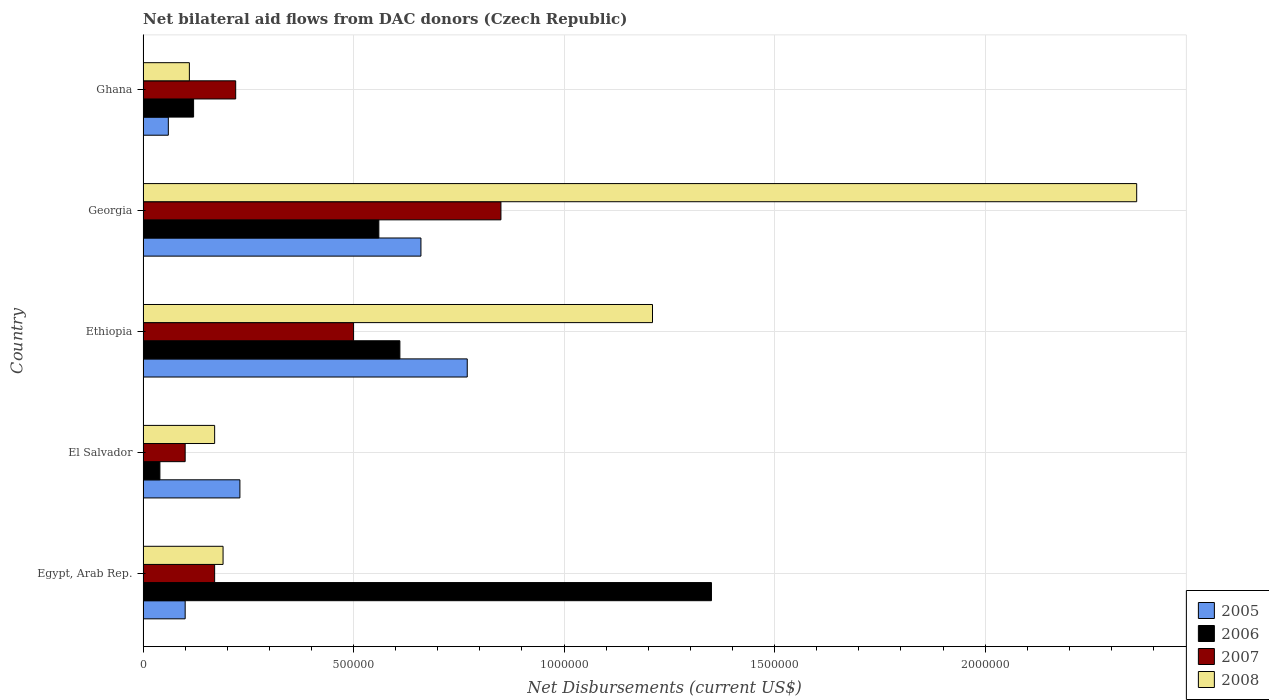How many different coloured bars are there?
Offer a very short reply. 4. How many groups of bars are there?
Offer a very short reply. 5. Are the number of bars per tick equal to the number of legend labels?
Provide a succinct answer. Yes. How many bars are there on the 5th tick from the top?
Provide a succinct answer. 4. How many bars are there on the 1st tick from the bottom?
Offer a very short reply. 4. What is the label of the 5th group of bars from the top?
Provide a succinct answer. Egypt, Arab Rep. Across all countries, what is the maximum net bilateral aid flows in 2008?
Give a very brief answer. 2.36e+06. Across all countries, what is the minimum net bilateral aid flows in 2005?
Offer a very short reply. 6.00e+04. In which country was the net bilateral aid flows in 2007 maximum?
Your answer should be very brief. Georgia. In which country was the net bilateral aid flows in 2007 minimum?
Your answer should be very brief. El Salvador. What is the total net bilateral aid flows in 2005 in the graph?
Your response must be concise. 1.82e+06. What is the difference between the net bilateral aid flows in 2008 in El Salvador and the net bilateral aid flows in 2006 in Ethiopia?
Give a very brief answer. -4.40e+05. What is the average net bilateral aid flows in 2005 per country?
Offer a very short reply. 3.64e+05. What is the difference between the net bilateral aid flows in 2008 and net bilateral aid flows in 2005 in Egypt, Arab Rep.?
Provide a succinct answer. 9.00e+04. What is the ratio of the net bilateral aid flows in 2007 in Georgia to that in Ghana?
Give a very brief answer. 3.86. What is the difference between the highest and the second highest net bilateral aid flows in 2006?
Make the answer very short. 7.40e+05. What is the difference between the highest and the lowest net bilateral aid flows in 2006?
Your response must be concise. 1.31e+06. In how many countries, is the net bilateral aid flows in 2008 greater than the average net bilateral aid flows in 2008 taken over all countries?
Provide a succinct answer. 2. Is the sum of the net bilateral aid flows in 2006 in Ethiopia and Ghana greater than the maximum net bilateral aid flows in 2008 across all countries?
Your answer should be compact. No. Is it the case that in every country, the sum of the net bilateral aid flows in 2008 and net bilateral aid flows in 2006 is greater than the sum of net bilateral aid flows in 2005 and net bilateral aid flows in 2007?
Your answer should be very brief. Yes. What does the 1st bar from the top in El Salvador represents?
Offer a very short reply. 2008. Is it the case that in every country, the sum of the net bilateral aid flows in 2005 and net bilateral aid flows in 2008 is greater than the net bilateral aid flows in 2006?
Give a very brief answer. No. How many bars are there?
Give a very brief answer. 20. Are all the bars in the graph horizontal?
Provide a short and direct response. Yes. How many countries are there in the graph?
Keep it short and to the point. 5. What is the difference between two consecutive major ticks on the X-axis?
Ensure brevity in your answer.  5.00e+05. Does the graph contain any zero values?
Keep it short and to the point. No. Where does the legend appear in the graph?
Your response must be concise. Bottom right. What is the title of the graph?
Your response must be concise. Net bilateral aid flows from DAC donors (Czech Republic). Does "1965" appear as one of the legend labels in the graph?
Your answer should be very brief. No. What is the label or title of the X-axis?
Your answer should be very brief. Net Disbursements (current US$). What is the label or title of the Y-axis?
Provide a succinct answer. Country. What is the Net Disbursements (current US$) in 2005 in Egypt, Arab Rep.?
Your answer should be compact. 1.00e+05. What is the Net Disbursements (current US$) in 2006 in Egypt, Arab Rep.?
Offer a very short reply. 1.35e+06. What is the Net Disbursements (current US$) of 2006 in El Salvador?
Your response must be concise. 4.00e+04. What is the Net Disbursements (current US$) of 2007 in El Salvador?
Offer a terse response. 1.00e+05. What is the Net Disbursements (current US$) of 2008 in El Salvador?
Keep it short and to the point. 1.70e+05. What is the Net Disbursements (current US$) of 2005 in Ethiopia?
Your answer should be very brief. 7.70e+05. What is the Net Disbursements (current US$) of 2008 in Ethiopia?
Ensure brevity in your answer.  1.21e+06. What is the Net Disbursements (current US$) in 2005 in Georgia?
Provide a succinct answer. 6.60e+05. What is the Net Disbursements (current US$) of 2006 in Georgia?
Offer a terse response. 5.60e+05. What is the Net Disbursements (current US$) of 2007 in Georgia?
Keep it short and to the point. 8.50e+05. What is the Net Disbursements (current US$) in 2008 in Georgia?
Your answer should be very brief. 2.36e+06. What is the Net Disbursements (current US$) of 2005 in Ghana?
Make the answer very short. 6.00e+04. Across all countries, what is the maximum Net Disbursements (current US$) in 2005?
Offer a terse response. 7.70e+05. Across all countries, what is the maximum Net Disbursements (current US$) in 2006?
Provide a short and direct response. 1.35e+06. Across all countries, what is the maximum Net Disbursements (current US$) of 2007?
Offer a terse response. 8.50e+05. Across all countries, what is the maximum Net Disbursements (current US$) in 2008?
Your answer should be very brief. 2.36e+06. Across all countries, what is the minimum Net Disbursements (current US$) of 2006?
Keep it short and to the point. 4.00e+04. What is the total Net Disbursements (current US$) in 2005 in the graph?
Provide a succinct answer. 1.82e+06. What is the total Net Disbursements (current US$) of 2006 in the graph?
Provide a short and direct response. 2.68e+06. What is the total Net Disbursements (current US$) in 2007 in the graph?
Offer a terse response. 1.84e+06. What is the total Net Disbursements (current US$) in 2008 in the graph?
Offer a terse response. 4.04e+06. What is the difference between the Net Disbursements (current US$) in 2005 in Egypt, Arab Rep. and that in El Salvador?
Provide a succinct answer. -1.30e+05. What is the difference between the Net Disbursements (current US$) of 2006 in Egypt, Arab Rep. and that in El Salvador?
Offer a terse response. 1.31e+06. What is the difference between the Net Disbursements (current US$) of 2007 in Egypt, Arab Rep. and that in El Salvador?
Ensure brevity in your answer.  7.00e+04. What is the difference between the Net Disbursements (current US$) of 2008 in Egypt, Arab Rep. and that in El Salvador?
Provide a short and direct response. 2.00e+04. What is the difference between the Net Disbursements (current US$) of 2005 in Egypt, Arab Rep. and that in Ethiopia?
Provide a short and direct response. -6.70e+05. What is the difference between the Net Disbursements (current US$) of 2006 in Egypt, Arab Rep. and that in Ethiopia?
Keep it short and to the point. 7.40e+05. What is the difference between the Net Disbursements (current US$) in 2007 in Egypt, Arab Rep. and that in Ethiopia?
Ensure brevity in your answer.  -3.30e+05. What is the difference between the Net Disbursements (current US$) in 2008 in Egypt, Arab Rep. and that in Ethiopia?
Your response must be concise. -1.02e+06. What is the difference between the Net Disbursements (current US$) in 2005 in Egypt, Arab Rep. and that in Georgia?
Your answer should be very brief. -5.60e+05. What is the difference between the Net Disbursements (current US$) in 2006 in Egypt, Arab Rep. and that in Georgia?
Ensure brevity in your answer.  7.90e+05. What is the difference between the Net Disbursements (current US$) in 2007 in Egypt, Arab Rep. and that in Georgia?
Keep it short and to the point. -6.80e+05. What is the difference between the Net Disbursements (current US$) in 2008 in Egypt, Arab Rep. and that in Georgia?
Ensure brevity in your answer.  -2.17e+06. What is the difference between the Net Disbursements (current US$) of 2005 in Egypt, Arab Rep. and that in Ghana?
Offer a very short reply. 4.00e+04. What is the difference between the Net Disbursements (current US$) of 2006 in Egypt, Arab Rep. and that in Ghana?
Make the answer very short. 1.23e+06. What is the difference between the Net Disbursements (current US$) of 2005 in El Salvador and that in Ethiopia?
Your answer should be very brief. -5.40e+05. What is the difference between the Net Disbursements (current US$) in 2006 in El Salvador and that in Ethiopia?
Offer a very short reply. -5.70e+05. What is the difference between the Net Disbursements (current US$) of 2007 in El Salvador and that in Ethiopia?
Offer a terse response. -4.00e+05. What is the difference between the Net Disbursements (current US$) in 2008 in El Salvador and that in Ethiopia?
Your answer should be very brief. -1.04e+06. What is the difference between the Net Disbursements (current US$) in 2005 in El Salvador and that in Georgia?
Provide a short and direct response. -4.30e+05. What is the difference between the Net Disbursements (current US$) in 2006 in El Salvador and that in Georgia?
Your response must be concise. -5.20e+05. What is the difference between the Net Disbursements (current US$) of 2007 in El Salvador and that in Georgia?
Provide a succinct answer. -7.50e+05. What is the difference between the Net Disbursements (current US$) of 2008 in El Salvador and that in Georgia?
Your answer should be very brief. -2.19e+06. What is the difference between the Net Disbursements (current US$) in 2005 in El Salvador and that in Ghana?
Make the answer very short. 1.70e+05. What is the difference between the Net Disbursements (current US$) of 2006 in Ethiopia and that in Georgia?
Provide a succinct answer. 5.00e+04. What is the difference between the Net Disbursements (current US$) in 2007 in Ethiopia and that in Georgia?
Your response must be concise. -3.50e+05. What is the difference between the Net Disbursements (current US$) of 2008 in Ethiopia and that in Georgia?
Your answer should be compact. -1.15e+06. What is the difference between the Net Disbursements (current US$) in 2005 in Ethiopia and that in Ghana?
Make the answer very short. 7.10e+05. What is the difference between the Net Disbursements (current US$) of 2008 in Ethiopia and that in Ghana?
Make the answer very short. 1.10e+06. What is the difference between the Net Disbursements (current US$) of 2005 in Georgia and that in Ghana?
Offer a terse response. 6.00e+05. What is the difference between the Net Disbursements (current US$) in 2006 in Georgia and that in Ghana?
Offer a very short reply. 4.40e+05. What is the difference between the Net Disbursements (current US$) in 2007 in Georgia and that in Ghana?
Your answer should be compact. 6.30e+05. What is the difference between the Net Disbursements (current US$) of 2008 in Georgia and that in Ghana?
Provide a succinct answer. 2.25e+06. What is the difference between the Net Disbursements (current US$) of 2005 in Egypt, Arab Rep. and the Net Disbursements (current US$) of 2008 in El Salvador?
Your answer should be very brief. -7.00e+04. What is the difference between the Net Disbursements (current US$) in 2006 in Egypt, Arab Rep. and the Net Disbursements (current US$) in 2007 in El Salvador?
Keep it short and to the point. 1.25e+06. What is the difference between the Net Disbursements (current US$) in 2006 in Egypt, Arab Rep. and the Net Disbursements (current US$) in 2008 in El Salvador?
Your answer should be very brief. 1.18e+06. What is the difference between the Net Disbursements (current US$) of 2005 in Egypt, Arab Rep. and the Net Disbursements (current US$) of 2006 in Ethiopia?
Your response must be concise. -5.10e+05. What is the difference between the Net Disbursements (current US$) in 2005 in Egypt, Arab Rep. and the Net Disbursements (current US$) in 2007 in Ethiopia?
Provide a succinct answer. -4.00e+05. What is the difference between the Net Disbursements (current US$) of 2005 in Egypt, Arab Rep. and the Net Disbursements (current US$) of 2008 in Ethiopia?
Your response must be concise. -1.11e+06. What is the difference between the Net Disbursements (current US$) of 2006 in Egypt, Arab Rep. and the Net Disbursements (current US$) of 2007 in Ethiopia?
Provide a short and direct response. 8.50e+05. What is the difference between the Net Disbursements (current US$) of 2007 in Egypt, Arab Rep. and the Net Disbursements (current US$) of 2008 in Ethiopia?
Provide a succinct answer. -1.04e+06. What is the difference between the Net Disbursements (current US$) in 2005 in Egypt, Arab Rep. and the Net Disbursements (current US$) in 2006 in Georgia?
Keep it short and to the point. -4.60e+05. What is the difference between the Net Disbursements (current US$) of 2005 in Egypt, Arab Rep. and the Net Disbursements (current US$) of 2007 in Georgia?
Give a very brief answer. -7.50e+05. What is the difference between the Net Disbursements (current US$) in 2005 in Egypt, Arab Rep. and the Net Disbursements (current US$) in 2008 in Georgia?
Give a very brief answer. -2.26e+06. What is the difference between the Net Disbursements (current US$) in 2006 in Egypt, Arab Rep. and the Net Disbursements (current US$) in 2007 in Georgia?
Offer a terse response. 5.00e+05. What is the difference between the Net Disbursements (current US$) of 2006 in Egypt, Arab Rep. and the Net Disbursements (current US$) of 2008 in Georgia?
Keep it short and to the point. -1.01e+06. What is the difference between the Net Disbursements (current US$) in 2007 in Egypt, Arab Rep. and the Net Disbursements (current US$) in 2008 in Georgia?
Make the answer very short. -2.19e+06. What is the difference between the Net Disbursements (current US$) in 2005 in Egypt, Arab Rep. and the Net Disbursements (current US$) in 2006 in Ghana?
Give a very brief answer. -2.00e+04. What is the difference between the Net Disbursements (current US$) in 2005 in Egypt, Arab Rep. and the Net Disbursements (current US$) in 2008 in Ghana?
Offer a very short reply. -10000. What is the difference between the Net Disbursements (current US$) of 2006 in Egypt, Arab Rep. and the Net Disbursements (current US$) of 2007 in Ghana?
Provide a short and direct response. 1.13e+06. What is the difference between the Net Disbursements (current US$) of 2006 in Egypt, Arab Rep. and the Net Disbursements (current US$) of 2008 in Ghana?
Provide a succinct answer. 1.24e+06. What is the difference between the Net Disbursements (current US$) in 2005 in El Salvador and the Net Disbursements (current US$) in 2006 in Ethiopia?
Make the answer very short. -3.80e+05. What is the difference between the Net Disbursements (current US$) in 2005 in El Salvador and the Net Disbursements (current US$) in 2007 in Ethiopia?
Your response must be concise. -2.70e+05. What is the difference between the Net Disbursements (current US$) of 2005 in El Salvador and the Net Disbursements (current US$) of 2008 in Ethiopia?
Your answer should be compact. -9.80e+05. What is the difference between the Net Disbursements (current US$) in 2006 in El Salvador and the Net Disbursements (current US$) in 2007 in Ethiopia?
Provide a short and direct response. -4.60e+05. What is the difference between the Net Disbursements (current US$) in 2006 in El Salvador and the Net Disbursements (current US$) in 2008 in Ethiopia?
Give a very brief answer. -1.17e+06. What is the difference between the Net Disbursements (current US$) in 2007 in El Salvador and the Net Disbursements (current US$) in 2008 in Ethiopia?
Your answer should be very brief. -1.11e+06. What is the difference between the Net Disbursements (current US$) of 2005 in El Salvador and the Net Disbursements (current US$) of 2006 in Georgia?
Your answer should be compact. -3.30e+05. What is the difference between the Net Disbursements (current US$) in 2005 in El Salvador and the Net Disbursements (current US$) in 2007 in Georgia?
Provide a short and direct response. -6.20e+05. What is the difference between the Net Disbursements (current US$) of 2005 in El Salvador and the Net Disbursements (current US$) of 2008 in Georgia?
Ensure brevity in your answer.  -2.13e+06. What is the difference between the Net Disbursements (current US$) of 2006 in El Salvador and the Net Disbursements (current US$) of 2007 in Georgia?
Offer a terse response. -8.10e+05. What is the difference between the Net Disbursements (current US$) of 2006 in El Salvador and the Net Disbursements (current US$) of 2008 in Georgia?
Provide a succinct answer. -2.32e+06. What is the difference between the Net Disbursements (current US$) in 2007 in El Salvador and the Net Disbursements (current US$) in 2008 in Georgia?
Provide a succinct answer. -2.26e+06. What is the difference between the Net Disbursements (current US$) in 2005 in El Salvador and the Net Disbursements (current US$) in 2006 in Ghana?
Your answer should be very brief. 1.10e+05. What is the difference between the Net Disbursements (current US$) in 2005 in Ethiopia and the Net Disbursements (current US$) in 2006 in Georgia?
Keep it short and to the point. 2.10e+05. What is the difference between the Net Disbursements (current US$) in 2005 in Ethiopia and the Net Disbursements (current US$) in 2008 in Georgia?
Your answer should be very brief. -1.59e+06. What is the difference between the Net Disbursements (current US$) of 2006 in Ethiopia and the Net Disbursements (current US$) of 2008 in Georgia?
Your answer should be very brief. -1.75e+06. What is the difference between the Net Disbursements (current US$) of 2007 in Ethiopia and the Net Disbursements (current US$) of 2008 in Georgia?
Offer a very short reply. -1.86e+06. What is the difference between the Net Disbursements (current US$) of 2005 in Ethiopia and the Net Disbursements (current US$) of 2006 in Ghana?
Keep it short and to the point. 6.50e+05. What is the difference between the Net Disbursements (current US$) in 2006 in Ethiopia and the Net Disbursements (current US$) in 2007 in Ghana?
Provide a succinct answer. 3.90e+05. What is the difference between the Net Disbursements (current US$) in 2005 in Georgia and the Net Disbursements (current US$) in 2006 in Ghana?
Give a very brief answer. 5.40e+05. What is the difference between the Net Disbursements (current US$) of 2005 in Georgia and the Net Disbursements (current US$) of 2007 in Ghana?
Ensure brevity in your answer.  4.40e+05. What is the difference between the Net Disbursements (current US$) in 2007 in Georgia and the Net Disbursements (current US$) in 2008 in Ghana?
Your answer should be very brief. 7.40e+05. What is the average Net Disbursements (current US$) of 2005 per country?
Ensure brevity in your answer.  3.64e+05. What is the average Net Disbursements (current US$) in 2006 per country?
Make the answer very short. 5.36e+05. What is the average Net Disbursements (current US$) of 2007 per country?
Offer a very short reply. 3.68e+05. What is the average Net Disbursements (current US$) in 2008 per country?
Ensure brevity in your answer.  8.08e+05. What is the difference between the Net Disbursements (current US$) of 2005 and Net Disbursements (current US$) of 2006 in Egypt, Arab Rep.?
Make the answer very short. -1.25e+06. What is the difference between the Net Disbursements (current US$) in 2005 and Net Disbursements (current US$) in 2007 in Egypt, Arab Rep.?
Provide a short and direct response. -7.00e+04. What is the difference between the Net Disbursements (current US$) in 2005 and Net Disbursements (current US$) in 2008 in Egypt, Arab Rep.?
Your response must be concise. -9.00e+04. What is the difference between the Net Disbursements (current US$) of 2006 and Net Disbursements (current US$) of 2007 in Egypt, Arab Rep.?
Provide a succinct answer. 1.18e+06. What is the difference between the Net Disbursements (current US$) in 2006 and Net Disbursements (current US$) in 2008 in Egypt, Arab Rep.?
Your answer should be compact. 1.16e+06. What is the difference between the Net Disbursements (current US$) in 2005 and Net Disbursements (current US$) in 2006 in El Salvador?
Provide a succinct answer. 1.90e+05. What is the difference between the Net Disbursements (current US$) of 2005 and Net Disbursements (current US$) of 2007 in El Salvador?
Give a very brief answer. 1.30e+05. What is the difference between the Net Disbursements (current US$) in 2005 and Net Disbursements (current US$) in 2008 in El Salvador?
Give a very brief answer. 6.00e+04. What is the difference between the Net Disbursements (current US$) of 2007 and Net Disbursements (current US$) of 2008 in El Salvador?
Offer a very short reply. -7.00e+04. What is the difference between the Net Disbursements (current US$) in 2005 and Net Disbursements (current US$) in 2008 in Ethiopia?
Offer a terse response. -4.40e+05. What is the difference between the Net Disbursements (current US$) in 2006 and Net Disbursements (current US$) in 2007 in Ethiopia?
Offer a terse response. 1.10e+05. What is the difference between the Net Disbursements (current US$) of 2006 and Net Disbursements (current US$) of 2008 in Ethiopia?
Ensure brevity in your answer.  -6.00e+05. What is the difference between the Net Disbursements (current US$) of 2007 and Net Disbursements (current US$) of 2008 in Ethiopia?
Ensure brevity in your answer.  -7.10e+05. What is the difference between the Net Disbursements (current US$) of 2005 and Net Disbursements (current US$) of 2008 in Georgia?
Your answer should be compact. -1.70e+06. What is the difference between the Net Disbursements (current US$) in 2006 and Net Disbursements (current US$) in 2008 in Georgia?
Your answer should be compact. -1.80e+06. What is the difference between the Net Disbursements (current US$) of 2007 and Net Disbursements (current US$) of 2008 in Georgia?
Ensure brevity in your answer.  -1.51e+06. What is the difference between the Net Disbursements (current US$) in 2005 and Net Disbursements (current US$) in 2006 in Ghana?
Give a very brief answer. -6.00e+04. What is the difference between the Net Disbursements (current US$) of 2005 and Net Disbursements (current US$) of 2007 in Ghana?
Your response must be concise. -1.60e+05. What is the difference between the Net Disbursements (current US$) of 2005 and Net Disbursements (current US$) of 2008 in Ghana?
Your answer should be very brief. -5.00e+04. What is the ratio of the Net Disbursements (current US$) of 2005 in Egypt, Arab Rep. to that in El Salvador?
Your response must be concise. 0.43. What is the ratio of the Net Disbursements (current US$) of 2006 in Egypt, Arab Rep. to that in El Salvador?
Make the answer very short. 33.75. What is the ratio of the Net Disbursements (current US$) in 2008 in Egypt, Arab Rep. to that in El Salvador?
Make the answer very short. 1.12. What is the ratio of the Net Disbursements (current US$) of 2005 in Egypt, Arab Rep. to that in Ethiopia?
Ensure brevity in your answer.  0.13. What is the ratio of the Net Disbursements (current US$) in 2006 in Egypt, Arab Rep. to that in Ethiopia?
Provide a short and direct response. 2.21. What is the ratio of the Net Disbursements (current US$) of 2007 in Egypt, Arab Rep. to that in Ethiopia?
Offer a very short reply. 0.34. What is the ratio of the Net Disbursements (current US$) of 2008 in Egypt, Arab Rep. to that in Ethiopia?
Your response must be concise. 0.16. What is the ratio of the Net Disbursements (current US$) of 2005 in Egypt, Arab Rep. to that in Georgia?
Keep it short and to the point. 0.15. What is the ratio of the Net Disbursements (current US$) in 2006 in Egypt, Arab Rep. to that in Georgia?
Your answer should be very brief. 2.41. What is the ratio of the Net Disbursements (current US$) of 2007 in Egypt, Arab Rep. to that in Georgia?
Ensure brevity in your answer.  0.2. What is the ratio of the Net Disbursements (current US$) in 2008 in Egypt, Arab Rep. to that in Georgia?
Your answer should be compact. 0.08. What is the ratio of the Net Disbursements (current US$) in 2006 in Egypt, Arab Rep. to that in Ghana?
Ensure brevity in your answer.  11.25. What is the ratio of the Net Disbursements (current US$) of 2007 in Egypt, Arab Rep. to that in Ghana?
Your answer should be compact. 0.77. What is the ratio of the Net Disbursements (current US$) of 2008 in Egypt, Arab Rep. to that in Ghana?
Offer a terse response. 1.73. What is the ratio of the Net Disbursements (current US$) in 2005 in El Salvador to that in Ethiopia?
Give a very brief answer. 0.3. What is the ratio of the Net Disbursements (current US$) of 2006 in El Salvador to that in Ethiopia?
Provide a succinct answer. 0.07. What is the ratio of the Net Disbursements (current US$) of 2008 in El Salvador to that in Ethiopia?
Provide a short and direct response. 0.14. What is the ratio of the Net Disbursements (current US$) in 2005 in El Salvador to that in Georgia?
Offer a very short reply. 0.35. What is the ratio of the Net Disbursements (current US$) in 2006 in El Salvador to that in Georgia?
Your answer should be compact. 0.07. What is the ratio of the Net Disbursements (current US$) of 2007 in El Salvador to that in Georgia?
Your response must be concise. 0.12. What is the ratio of the Net Disbursements (current US$) in 2008 in El Salvador to that in Georgia?
Your response must be concise. 0.07. What is the ratio of the Net Disbursements (current US$) in 2005 in El Salvador to that in Ghana?
Give a very brief answer. 3.83. What is the ratio of the Net Disbursements (current US$) of 2007 in El Salvador to that in Ghana?
Give a very brief answer. 0.45. What is the ratio of the Net Disbursements (current US$) of 2008 in El Salvador to that in Ghana?
Ensure brevity in your answer.  1.55. What is the ratio of the Net Disbursements (current US$) in 2005 in Ethiopia to that in Georgia?
Keep it short and to the point. 1.17. What is the ratio of the Net Disbursements (current US$) in 2006 in Ethiopia to that in Georgia?
Provide a short and direct response. 1.09. What is the ratio of the Net Disbursements (current US$) in 2007 in Ethiopia to that in Georgia?
Your response must be concise. 0.59. What is the ratio of the Net Disbursements (current US$) in 2008 in Ethiopia to that in Georgia?
Offer a very short reply. 0.51. What is the ratio of the Net Disbursements (current US$) of 2005 in Ethiopia to that in Ghana?
Provide a short and direct response. 12.83. What is the ratio of the Net Disbursements (current US$) of 2006 in Ethiopia to that in Ghana?
Ensure brevity in your answer.  5.08. What is the ratio of the Net Disbursements (current US$) in 2007 in Ethiopia to that in Ghana?
Your answer should be compact. 2.27. What is the ratio of the Net Disbursements (current US$) of 2006 in Georgia to that in Ghana?
Keep it short and to the point. 4.67. What is the ratio of the Net Disbursements (current US$) of 2007 in Georgia to that in Ghana?
Make the answer very short. 3.86. What is the ratio of the Net Disbursements (current US$) in 2008 in Georgia to that in Ghana?
Ensure brevity in your answer.  21.45. What is the difference between the highest and the second highest Net Disbursements (current US$) in 2006?
Make the answer very short. 7.40e+05. What is the difference between the highest and the second highest Net Disbursements (current US$) of 2007?
Offer a very short reply. 3.50e+05. What is the difference between the highest and the second highest Net Disbursements (current US$) of 2008?
Ensure brevity in your answer.  1.15e+06. What is the difference between the highest and the lowest Net Disbursements (current US$) of 2005?
Your response must be concise. 7.10e+05. What is the difference between the highest and the lowest Net Disbursements (current US$) of 2006?
Ensure brevity in your answer.  1.31e+06. What is the difference between the highest and the lowest Net Disbursements (current US$) in 2007?
Give a very brief answer. 7.50e+05. What is the difference between the highest and the lowest Net Disbursements (current US$) of 2008?
Provide a succinct answer. 2.25e+06. 